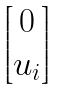<formula> <loc_0><loc_0><loc_500><loc_500>\begin{bmatrix} 0 \\ u _ { i } \end{bmatrix}</formula> 